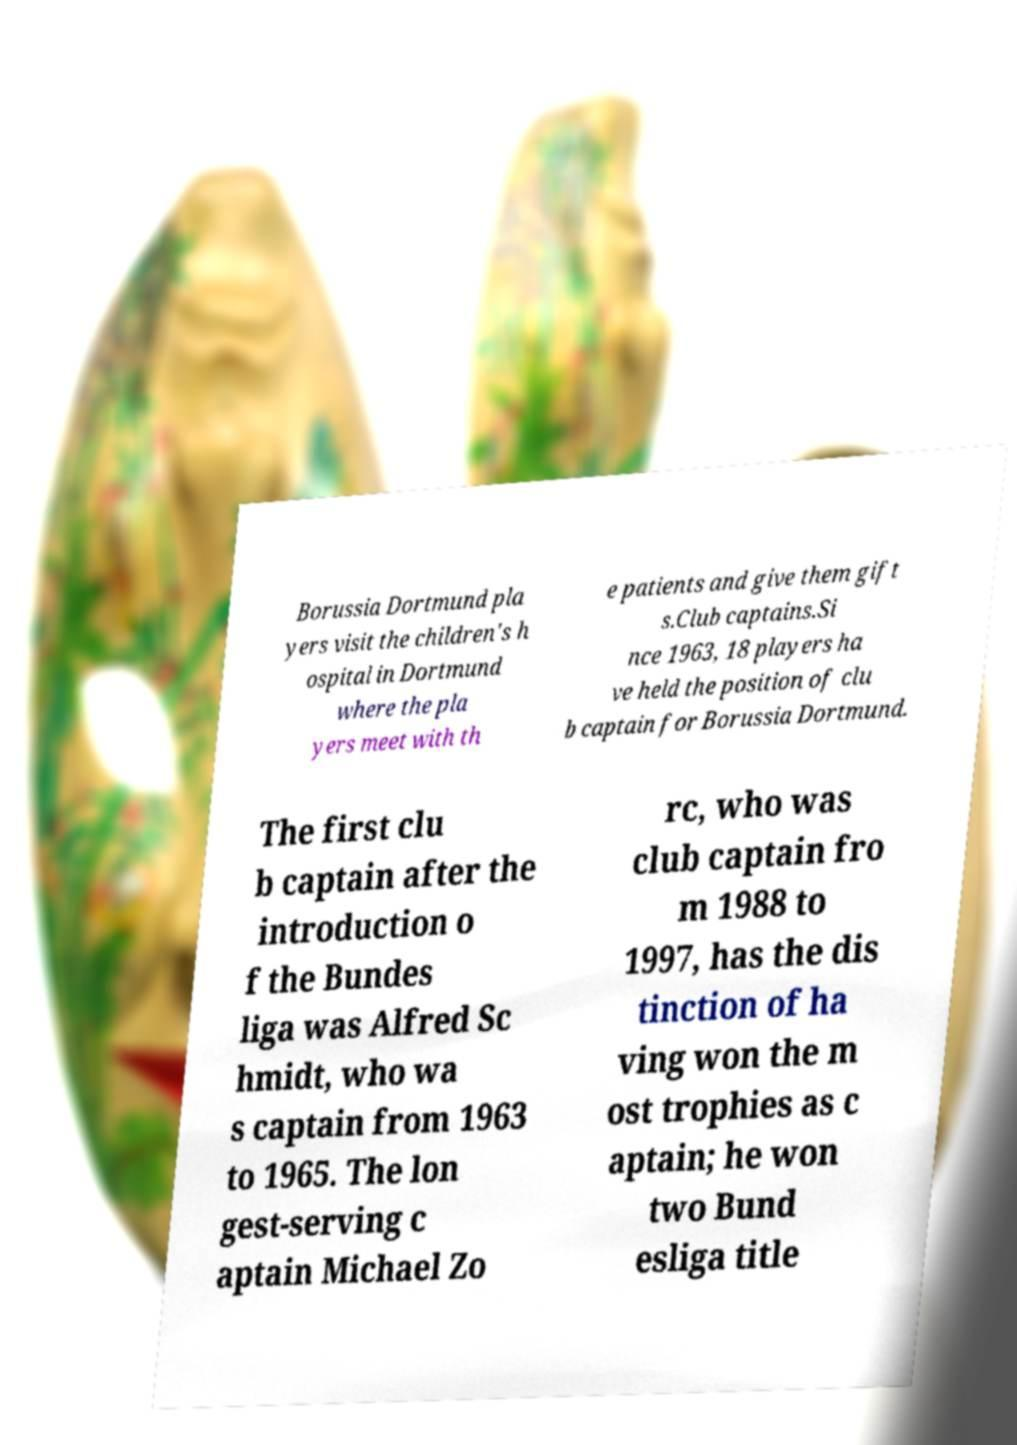Please read and relay the text visible in this image. What does it say? Borussia Dortmund pla yers visit the children's h ospital in Dortmund where the pla yers meet with th e patients and give them gift s.Club captains.Si nce 1963, 18 players ha ve held the position of clu b captain for Borussia Dortmund. The first clu b captain after the introduction o f the Bundes liga was Alfred Sc hmidt, who wa s captain from 1963 to 1965. The lon gest-serving c aptain Michael Zo rc, who was club captain fro m 1988 to 1997, has the dis tinction of ha ving won the m ost trophies as c aptain; he won two Bund esliga title 